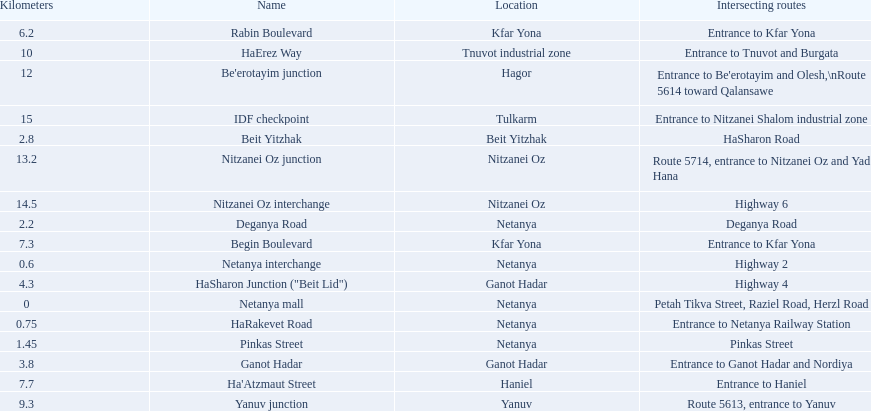What are all of the different portions? Netanya mall, Netanya interchange, HaRakevet Road, Pinkas Street, Deganya Road, Beit Yitzhak, Ganot Hadar, HaSharon Junction ("Beit Lid"), Rabin Boulevard, Begin Boulevard, Ha'Atzmaut Street, Yanuv junction, HaErez Way, Be'erotayim junction, Nitzanei Oz junction, Nitzanei Oz interchange, IDF checkpoint. What is the intersecting route for rabin boulevard? Entrance to Kfar Yona. What portion also has an intersecting route of entrance to kfar yona? Begin Boulevard. 